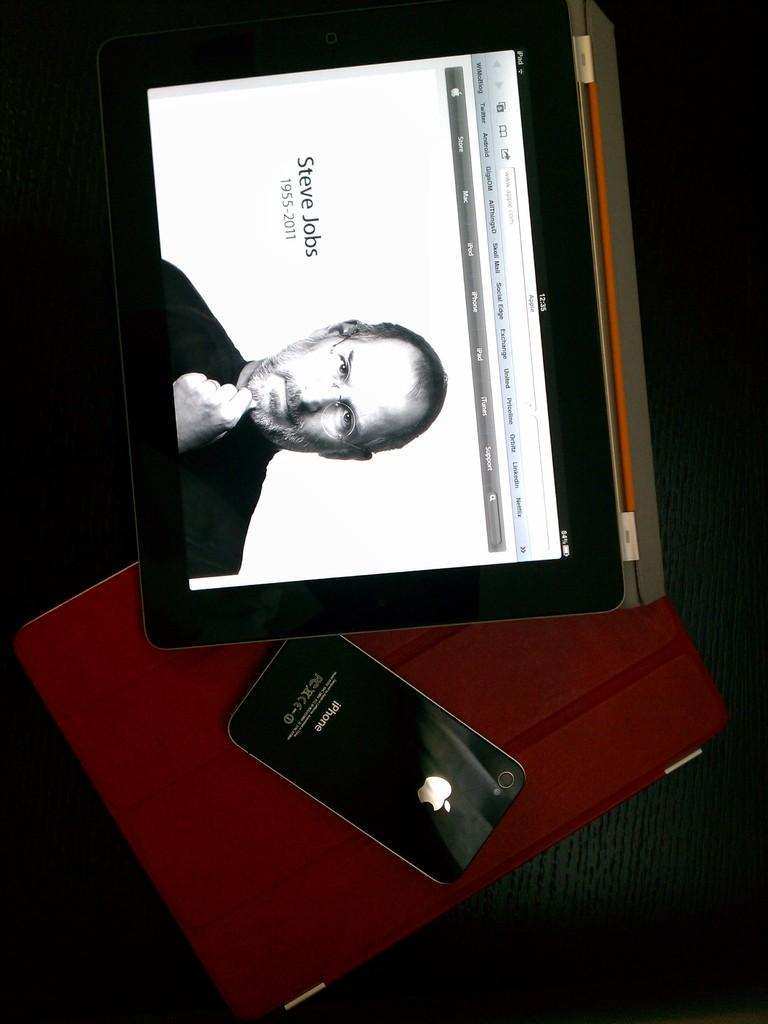Provide a one-sentence caption for the provided image. An iPhone is placed next to a picture of Steve Jobs. 